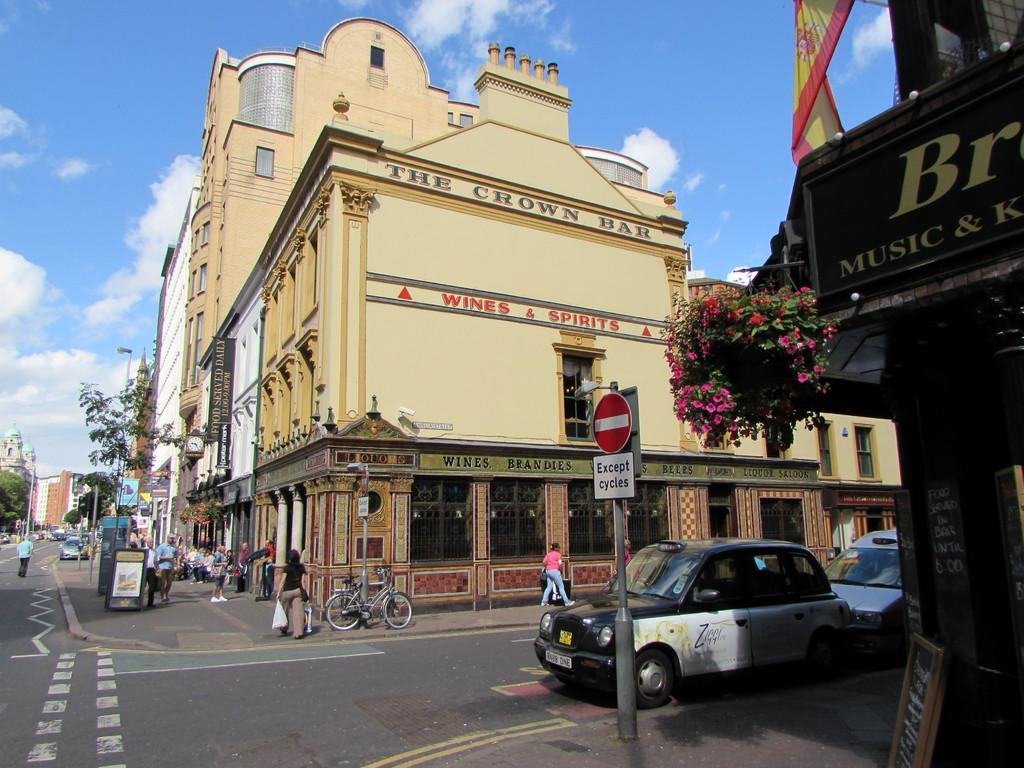<image>
Share a concise interpretation of the image provided. Streets full of people and cars with a crown bar 